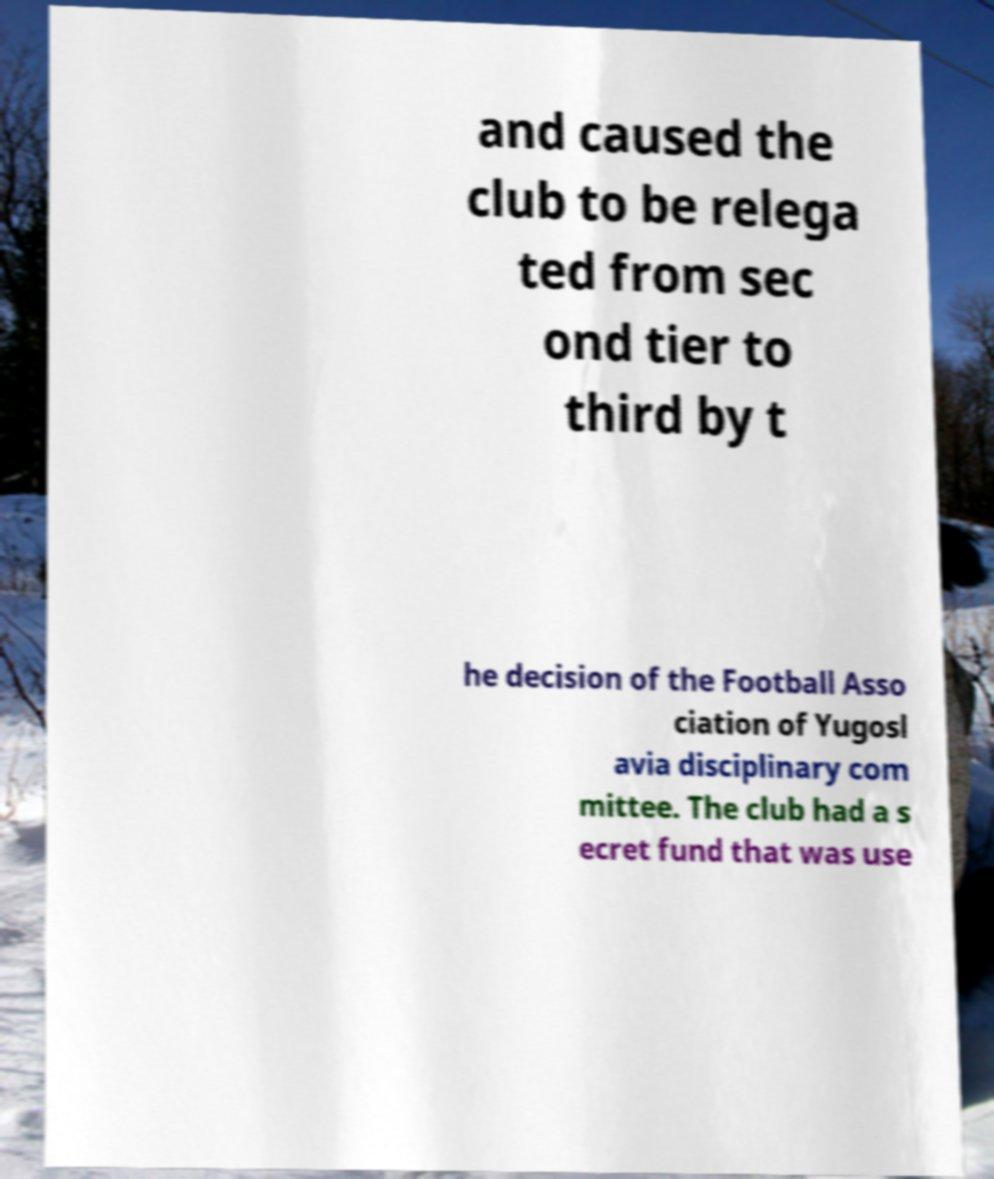Please read and relay the text visible in this image. What does it say? and caused the club to be relega ted from sec ond tier to third by t he decision of the Football Asso ciation of Yugosl avia disciplinary com mittee. The club had a s ecret fund that was use 